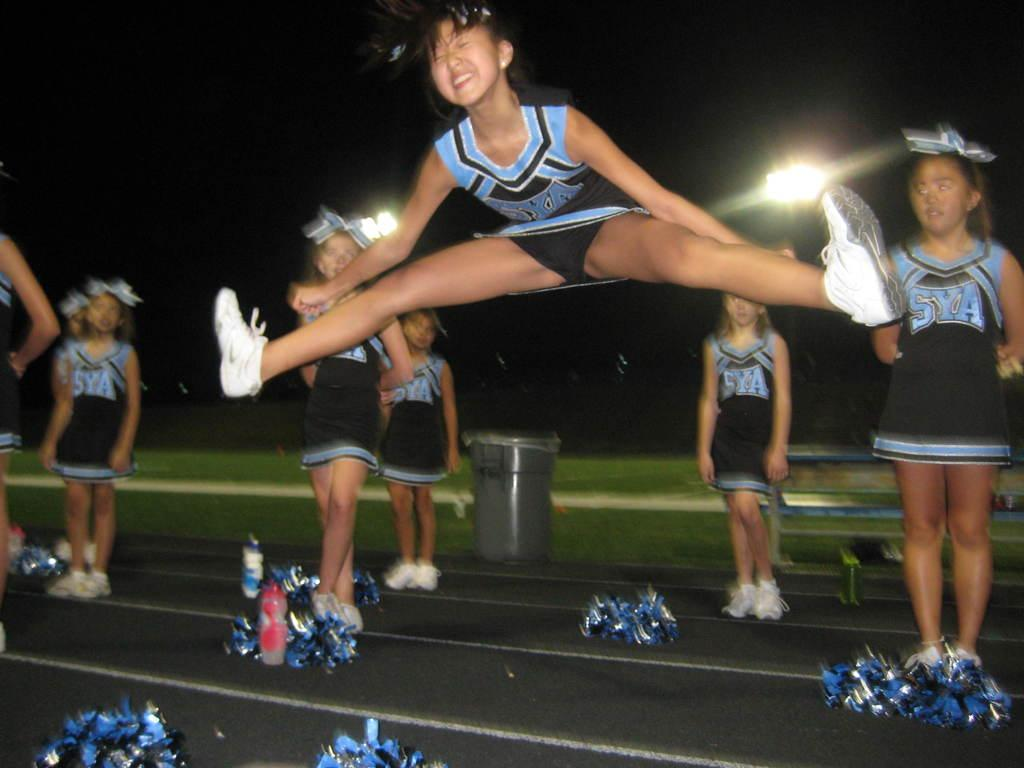<image>
Present a compact description of the photo's key features. The cheerleading squad is cheering for team SYA. 